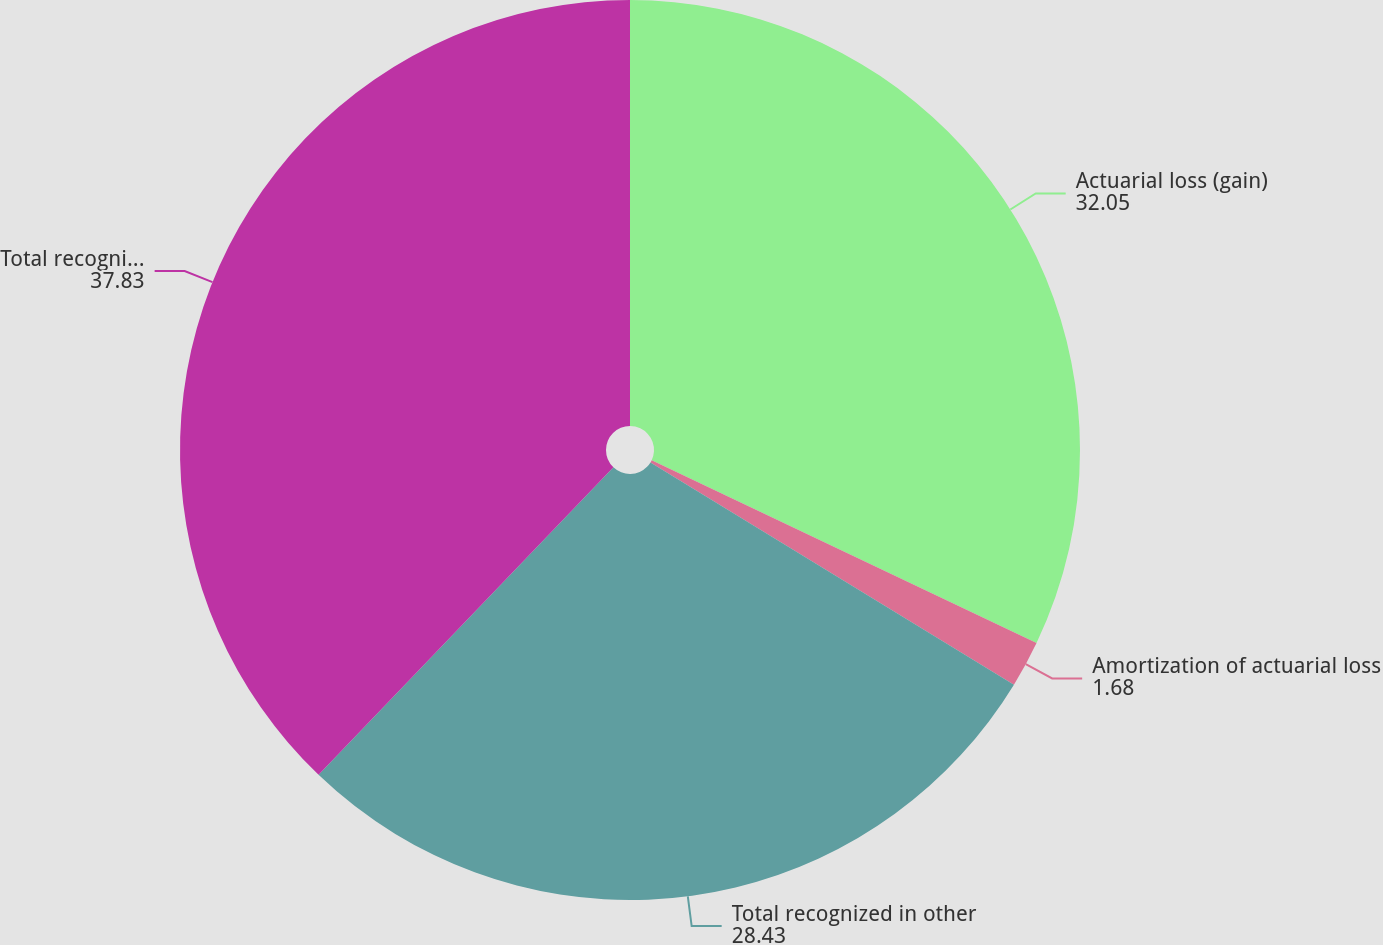Convert chart to OTSL. <chart><loc_0><loc_0><loc_500><loc_500><pie_chart><fcel>Actuarial loss (gain)<fcel>Amortization of actuarial loss<fcel>Total recognized in other<fcel>Total recognized in net<nl><fcel>32.05%<fcel>1.68%<fcel>28.43%<fcel>37.83%<nl></chart> 